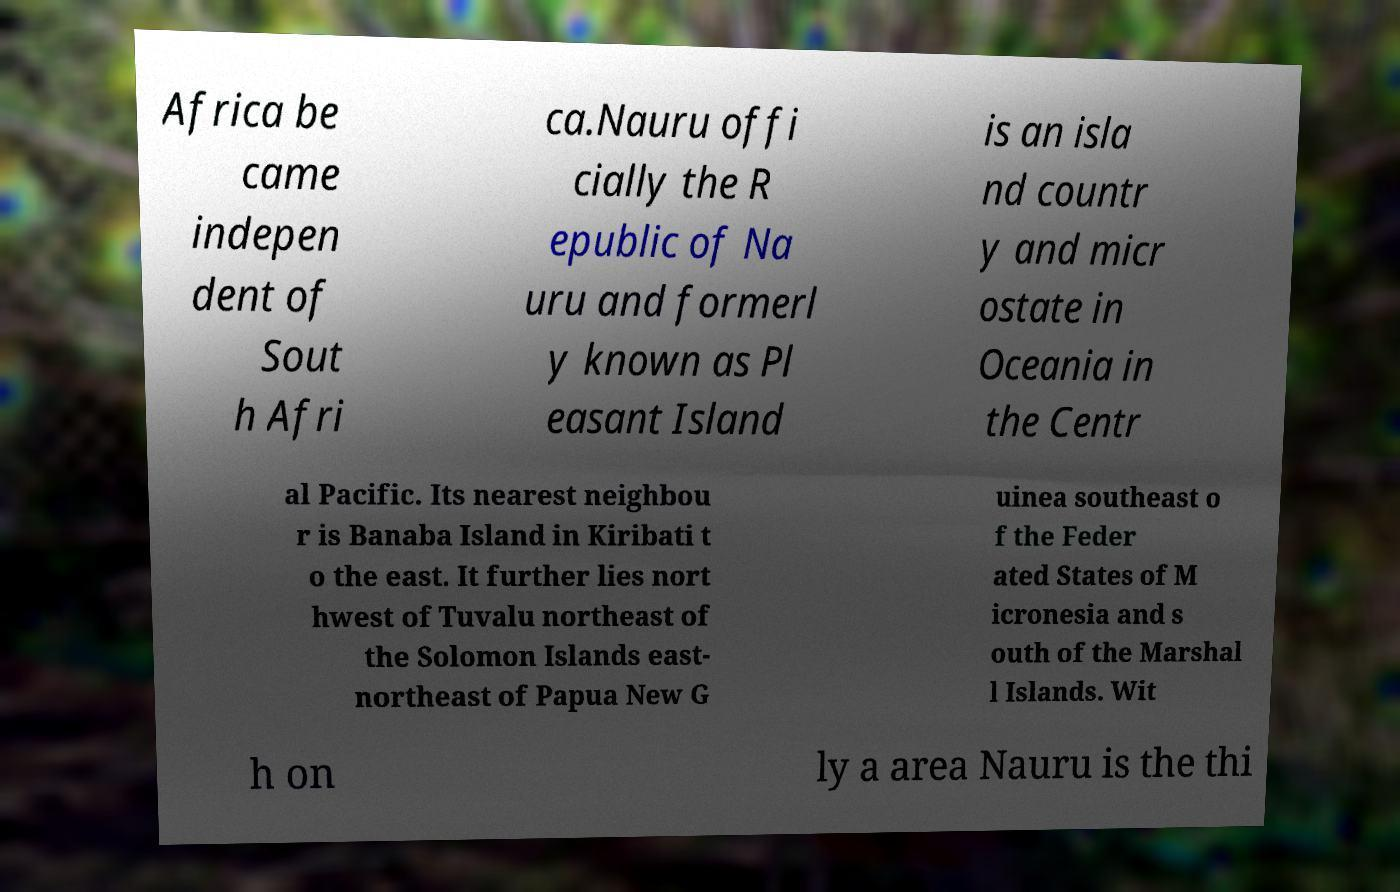Please identify and transcribe the text found in this image. Africa be came indepen dent of Sout h Afri ca.Nauru offi cially the R epublic of Na uru and formerl y known as Pl easant Island is an isla nd countr y and micr ostate in Oceania in the Centr al Pacific. Its nearest neighbou r is Banaba Island in Kiribati t o the east. It further lies nort hwest of Tuvalu northeast of the Solomon Islands east- northeast of Papua New G uinea southeast o f the Feder ated States of M icronesia and s outh of the Marshal l Islands. Wit h on ly a area Nauru is the thi 